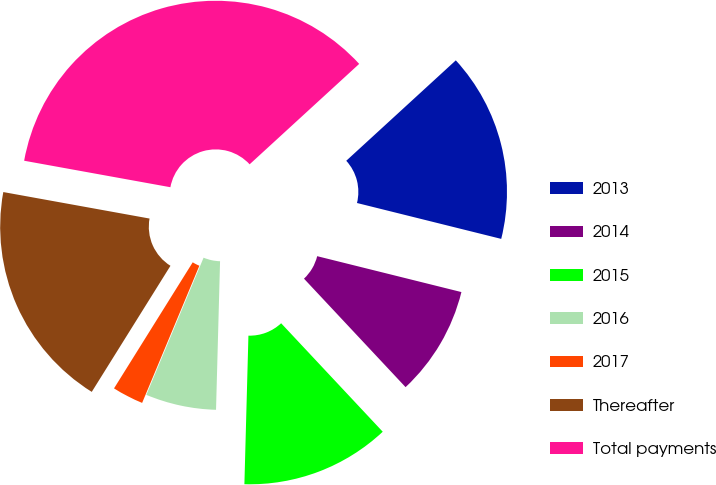Convert chart to OTSL. <chart><loc_0><loc_0><loc_500><loc_500><pie_chart><fcel>2013<fcel>2014<fcel>2015<fcel>2016<fcel>2017<fcel>Thereafter<fcel>Total payments<nl><fcel>15.69%<fcel>9.14%<fcel>12.41%<fcel>5.86%<fcel>2.59%<fcel>18.97%<fcel>35.34%<nl></chart> 